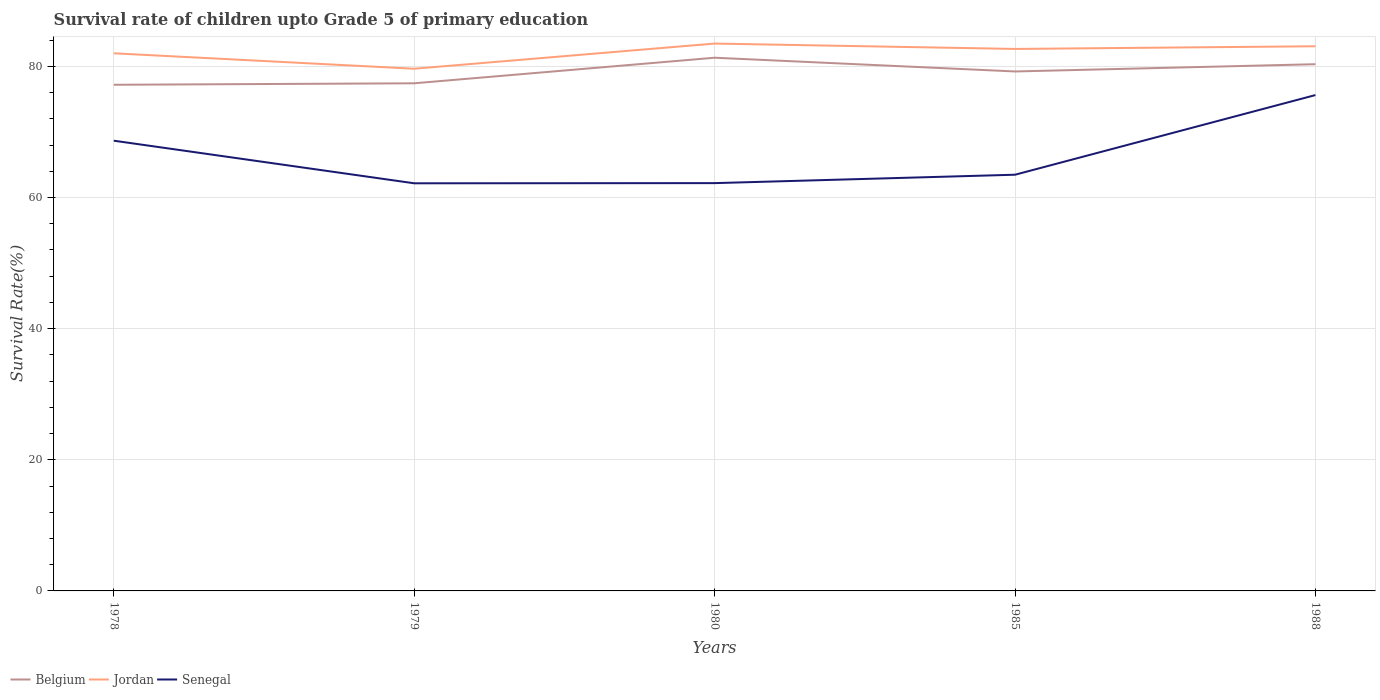Does the line corresponding to Jordan intersect with the line corresponding to Senegal?
Provide a succinct answer. No. Across all years, what is the maximum survival rate of children in Senegal?
Your answer should be compact. 62.16. In which year was the survival rate of children in Senegal maximum?
Make the answer very short. 1979. What is the total survival rate of children in Jordan in the graph?
Your response must be concise. -3.42. What is the difference between the highest and the second highest survival rate of children in Senegal?
Make the answer very short. 13.45. What is the difference between the highest and the lowest survival rate of children in Jordan?
Keep it short and to the point. 3. Is the survival rate of children in Belgium strictly greater than the survival rate of children in Senegal over the years?
Provide a short and direct response. No. Are the values on the major ticks of Y-axis written in scientific E-notation?
Make the answer very short. No. Does the graph contain any zero values?
Keep it short and to the point. No. Does the graph contain grids?
Provide a succinct answer. Yes. How many legend labels are there?
Your answer should be very brief. 3. What is the title of the graph?
Offer a terse response. Survival rate of children upto Grade 5 of primary education. Does "Sub-Saharan Africa (all income levels)" appear as one of the legend labels in the graph?
Your answer should be very brief. No. What is the label or title of the Y-axis?
Make the answer very short. Survival Rate(%). What is the Survival Rate(%) in Belgium in 1978?
Your answer should be very brief. 77.19. What is the Survival Rate(%) of Jordan in 1978?
Offer a very short reply. 81.99. What is the Survival Rate(%) of Senegal in 1978?
Your answer should be compact. 68.66. What is the Survival Rate(%) in Belgium in 1979?
Make the answer very short. 77.41. What is the Survival Rate(%) in Jordan in 1979?
Offer a terse response. 79.63. What is the Survival Rate(%) of Senegal in 1979?
Give a very brief answer. 62.16. What is the Survival Rate(%) of Belgium in 1980?
Give a very brief answer. 81.31. What is the Survival Rate(%) of Jordan in 1980?
Make the answer very short. 83.47. What is the Survival Rate(%) in Senegal in 1980?
Keep it short and to the point. 62.19. What is the Survival Rate(%) in Belgium in 1985?
Your response must be concise. 79.22. What is the Survival Rate(%) in Jordan in 1985?
Make the answer very short. 82.65. What is the Survival Rate(%) of Senegal in 1985?
Provide a succinct answer. 63.47. What is the Survival Rate(%) in Belgium in 1988?
Offer a very short reply. 80.32. What is the Survival Rate(%) in Jordan in 1988?
Ensure brevity in your answer.  83.06. What is the Survival Rate(%) in Senegal in 1988?
Offer a terse response. 75.62. Across all years, what is the maximum Survival Rate(%) of Belgium?
Provide a succinct answer. 81.31. Across all years, what is the maximum Survival Rate(%) in Jordan?
Keep it short and to the point. 83.47. Across all years, what is the maximum Survival Rate(%) of Senegal?
Ensure brevity in your answer.  75.62. Across all years, what is the minimum Survival Rate(%) of Belgium?
Offer a very short reply. 77.19. Across all years, what is the minimum Survival Rate(%) of Jordan?
Provide a short and direct response. 79.63. Across all years, what is the minimum Survival Rate(%) of Senegal?
Keep it short and to the point. 62.16. What is the total Survival Rate(%) in Belgium in the graph?
Your answer should be compact. 395.46. What is the total Survival Rate(%) in Jordan in the graph?
Offer a terse response. 410.81. What is the total Survival Rate(%) of Senegal in the graph?
Give a very brief answer. 332.1. What is the difference between the Survival Rate(%) of Belgium in 1978 and that in 1979?
Offer a very short reply. -0.22. What is the difference between the Survival Rate(%) in Jordan in 1978 and that in 1979?
Ensure brevity in your answer.  2.35. What is the difference between the Survival Rate(%) in Senegal in 1978 and that in 1979?
Your response must be concise. 6.5. What is the difference between the Survival Rate(%) in Belgium in 1978 and that in 1980?
Keep it short and to the point. -4.12. What is the difference between the Survival Rate(%) in Jordan in 1978 and that in 1980?
Ensure brevity in your answer.  -1.48. What is the difference between the Survival Rate(%) in Senegal in 1978 and that in 1980?
Your answer should be compact. 6.47. What is the difference between the Survival Rate(%) of Belgium in 1978 and that in 1985?
Ensure brevity in your answer.  -2.03. What is the difference between the Survival Rate(%) of Jordan in 1978 and that in 1985?
Your answer should be very brief. -0.67. What is the difference between the Survival Rate(%) in Senegal in 1978 and that in 1985?
Offer a terse response. 5.19. What is the difference between the Survival Rate(%) in Belgium in 1978 and that in 1988?
Provide a short and direct response. -3.13. What is the difference between the Survival Rate(%) in Jordan in 1978 and that in 1988?
Make the answer very short. -1.07. What is the difference between the Survival Rate(%) in Senegal in 1978 and that in 1988?
Provide a short and direct response. -6.96. What is the difference between the Survival Rate(%) of Belgium in 1979 and that in 1980?
Ensure brevity in your answer.  -3.9. What is the difference between the Survival Rate(%) of Jordan in 1979 and that in 1980?
Give a very brief answer. -3.84. What is the difference between the Survival Rate(%) of Senegal in 1979 and that in 1980?
Provide a short and direct response. -0.02. What is the difference between the Survival Rate(%) of Belgium in 1979 and that in 1985?
Provide a succinct answer. -1.8. What is the difference between the Survival Rate(%) in Jordan in 1979 and that in 1985?
Your response must be concise. -3.02. What is the difference between the Survival Rate(%) of Senegal in 1979 and that in 1985?
Your answer should be compact. -1.31. What is the difference between the Survival Rate(%) in Belgium in 1979 and that in 1988?
Provide a short and direct response. -2.91. What is the difference between the Survival Rate(%) in Jordan in 1979 and that in 1988?
Provide a succinct answer. -3.42. What is the difference between the Survival Rate(%) of Senegal in 1979 and that in 1988?
Keep it short and to the point. -13.45. What is the difference between the Survival Rate(%) of Belgium in 1980 and that in 1985?
Make the answer very short. 2.1. What is the difference between the Survival Rate(%) of Jordan in 1980 and that in 1985?
Make the answer very short. 0.82. What is the difference between the Survival Rate(%) of Senegal in 1980 and that in 1985?
Your answer should be very brief. -1.28. What is the difference between the Survival Rate(%) in Belgium in 1980 and that in 1988?
Make the answer very short. 0.99. What is the difference between the Survival Rate(%) of Jordan in 1980 and that in 1988?
Make the answer very short. 0.41. What is the difference between the Survival Rate(%) of Senegal in 1980 and that in 1988?
Your response must be concise. -13.43. What is the difference between the Survival Rate(%) in Belgium in 1985 and that in 1988?
Provide a short and direct response. -1.11. What is the difference between the Survival Rate(%) in Jordan in 1985 and that in 1988?
Offer a very short reply. -0.41. What is the difference between the Survival Rate(%) of Senegal in 1985 and that in 1988?
Your response must be concise. -12.15. What is the difference between the Survival Rate(%) in Belgium in 1978 and the Survival Rate(%) in Jordan in 1979?
Give a very brief answer. -2.44. What is the difference between the Survival Rate(%) in Belgium in 1978 and the Survival Rate(%) in Senegal in 1979?
Your answer should be very brief. 15.03. What is the difference between the Survival Rate(%) in Jordan in 1978 and the Survival Rate(%) in Senegal in 1979?
Keep it short and to the point. 19.82. What is the difference between the Survival Rate(%) of Belgium in 1978 and the Survival Rate(%) of Jordan in 1980?
Offer a terse response. -6.28. What is the difference between the Survival Rate(%) in Belgium in 1978 and the Survival Rate(%) in Senegal in 1980?
Your response must be concise. 15. What is the difference between the Survival Rate(%) of Jordan in 1978 and the Survival Rate(%) of Senegal in 1980?
Offer a terse response. 19.8. What is the difference between the Survival Rate(%) in Belgium in 1978 and the Survival Rate(%) in Jordan in 1985?
Your response must be concise. -5.46. What is the difference between the Survival Rate(%) of Belgium in 1978 and the Survival Rate(%) of Senegal in 1985?
Make the answer very short. 13.72. What is the difference between the Survival Rate(%) of Jordan in 1978 and the Survival Rate(%) of Senegal in 1985?
Your response must be concise. 18.52. What is the difference between the Survival Rate(%) in Belgium in 1978 and the Survival Rate(%) in Jordan in 1988?
Your answer should be very brief. -5.87. What is the difference between the Survival Rate(%) of Belgium in 1978 and the Survival Rate(%) of Senegal in 1988?
Your answer should be compact. 1.57. What is the difference between the Survival Rate(%) in Jordan in 1978 and the Survival Rate(%) in Senegal in 1988?
Your response must be concise. 6.37. What is the difference between the Survival Rate(%) in Belgium in 1979 and the Survival Rate(%) in Jordan in 1980?
Ensure brevity in your answer.  -6.06. What is the difference between the Survival Rate(%) in Belgium in 1979 and the Survival Rate(%) in Senegal in 1980?
Give a very brief answer. 15.23. What is the difference between the Survival Rate(%) in Jordan in 1979 and the Survival Rate(%) in Senegal in 1980?
Offer a terse response. 17.45. What is the difference between the Survival Rate(%) of Belgium in 1979 and the Survival Rate(%) of Jordan in 1985?
Your response must be concise. -5.24. What is the difference between the Survival Rate(%) of Belgium in 1979 and the Survival Rate(%) of Senegal in 1985?
Provide a succinct answer. 13.94. What is the difference between the Survival Rate(%) of Jordan in 1979 and the Survival Rate(%) of Senegal in 1985?
Offer a terse response. 16.16. What is the difference between the Survival Rate(%) of Belgium in 1979 and the Survival Rate(%) of Jordan in 1988?
Give a very brief answer. -5.65. What is the difference between the Survival Rate(%) in Belgium in 1979 and the Survival Rate(%) in Senegal in 1988?
Your answer should be very brief. 1.8. What is the difference between the Survival Rate(%) in Jordan in 1979 and the Survival Rate(%) in Senegal in 1988?
Your answer should be very brief. 4.02. What is the difference between the Survival Rate(%) in Belgium in 1980 and the Survival Rate(%) in Jordan in 1985?
Provide a short and direct response. -1.34. What is the difference between the Survival Rate(%) in Belgium in 1980 and the Survival Rate(%) in Senegal in 1985?
Offer a very short reply. 17.84. What is the difference between the Survival Rate(%) of Jordan in 1980 and the Survival Rate(%) of Senegal in 1985?
Ensure brevity in your answer.  20. What is the difference between the Survival Rate(%) in Belgium in 1980 and the Survival Rate(%) in Jordan in 1988?
Provide a short and direct response. -1.75. What is the difference between the Survival Rate(%) in Belgium in 1980 and the Survival Rate(%) in Senegal in 1988?
Your answer should be compact. 5.7. What is the difference between the Survival Rate(%) in Jordan in 1980 and the Survival Rate(%) in Senegal in 1988?
Keep it short and to the point. 7.86. What is the difference between the Survival Rate(%) in Belgium in 1985 and the Survival Rate(%) in Jordan in 1988?
Your answer should be very brief. -3.84. What is the difference between the Survival Rate(%) of Belgium in 1985 and the Survival Rate(%) of Senegal in 1988?
Your answer should be very brief. 3.6. What is the difference between the Survival Rate(%) in Jordan in 1985 and the Survival Rate(%) in Senegal in 1988?
Provide a short and direct response. 7.04. What is the average Survival Rate(%) of Belgium per year?
Your answer should be compact. 79.09. What is the average Survival Rate(%) in Jordan per year?
Keep it short and to the point. 82.16. What is the average Survival Rate(%) in Senegal per year?
Provide a short and direct response. 66.42. In the year 1978, what is the difference between the Survival Rate(%) of Belgium and Survival Rate(%) of Jordan?
Offer a very short reply. -4.8. In the year 1978, what is the difference between the Survival Rate(%) in Belgium and Survival Rate(%) in Senegal?
Provide a succinct answer. 8.53. In the year 1978, what is the difference between the Survival Rate(%) in Jordan and Survival Rate(%) in Senegal?
Ensure brevity in your answer.  13.33. In the year 1979, what is the difference between the Survival Rate(%) of Belgium and Survival Rate(%) of Jordan?
Keep it short and to the point. -2.22. In the year 1979, what is the difference between the Survival Rate(%) in Belgium and Survival Rate(%) in Senegal?
Give a very brief answer. 15.25. In the year 1979, what is the difference between the Survival Rate(%) of Jordan and Survival Rate(%) of Senegal?
Your answer should be compact. 17.47. In the year 1980, what is the difference between the Survival Rate(%) in Belgium and Survival Rate(%) in Jordan?
Make the answer very short. -2.16. In the year 1980, what is the difference between the Survival Rate(%) of Belgium and Survival Rate(%) of Senegal?
Provide a succinct answer. 19.12. In the year 1980, what is the difference between the Survival Rate(%) in Jordan and Survival Rate(%) in Senegal?
Offer a terse response. 21.28. In the year 1985, what is the difference between the Survival Rate(%) of Belgium and Survival Rate(%) of Jordan?
Make the answer very short. -3.44. In the year 1985, what is the difference between the Survival Rate(%) in Belgium and Survival Rate(%) in Senegal?
Give a very brief answer. 15.75. In the year 1985, what is the difference between the Survival Rate(%) in Jordan and Survival Rate(%) in Senegal?
Provide a short and direct response. 19.18. In the year 1988, what is the difference between the Survival Rate(%) of Belgium and Survival Rate(%) of Jordan?
Your response must be concise. -2.73. In the year 1988, what is the difference between the Survival Rate(%) in Belgium and Survival Rate(%) in Senegal?
Ensure brevity in your answer.  4.71. In the year 1988, what is the difference between the Survival Rate(%) in Jordan and Survival Rate(%) in Senegal?
Your answer should be very brief. 7.44. What is the ratio of the Survival Rate(%) of Jordan in 1978 to that in 1979?
Give a very brief answer. 1.03. What is the ratio of the Survival Rate(%) of Senegal in 1978 to that in 1979?
Keep it short and to the point. 1.1. What is the ratio of the Survival Rate(%) of Belgium in 1978 to that in 1980?
Offer a terse response. 0.95. What is the ratio of the Survival Rate(%) of Jordan in 1978 to that in 1980?
Your answer should be compact. 0.98. What is the ratio of the Survival Rate(%) in Senegal in 1978 to that in 1980?
Your answer should be compact. 1.1. What is the ratio of the Survival Rate(%) of Belgium in 1978 to that in 1985?
Your answer should be very brief. 0.97. What is the ratio of the Survival Rate(%) of Jordan in 1978 to that in 1985?
Provide a short and direct response. 0.99. What is the ratio of the Survival Rate(%) of Senegal in 1978 to that in 1985?
Give a very brief answer. 1.08. What is the ratio of the Survival Rate(%) in Jordan in 1978 to that in 1988?
Your response must be concise. 0.99. What is the ratio of the Survival Rate(%) of Senegal in 1978 to that in 1988?
Provide a short and direct response. 0.91. What is the ratio of the Survival Rate(%) in Belgium in 1979 to that in 1980?
Your response must be concise. 0.95. What is the ratio of the Survival Rate(%) of Jordan in 1979 to that in 1980?
Keep it short and to the point. 0.95. What is the ratio of the Survival Rate(%) in Senegal in 1979 to that in 1980?
Provide a succinct answer. 1. What is the ratio of the Survival Rate(%) in Belgium in 1979 to that in 1985?
Make the answer very short. 0.98. What is the ratio of the Survival Rate(%) in Jordan in 1979 to that in 1985?
Your answer should be compact. 0.96. What is the ratio of the Survival Rate(%) of Senegal in 1979 to that in 1985?
Offer a very short reply. 0.98. What is the ratio of the Survival Rate(%) in Belgium in 1979 to that in 1988?
Ensure brevity in your answer.  0.96. What is the ratio of the Survival Rate(%) in Jordan in 1979 to that in 1988?
Your answer should be compact. 0.96. What is the ratio of the Survival Rate(%) of Senegal in 1979 to that in 1988?
Ensure brevity in your answer.  0.82. What is the ratio of the Survival Rate(%) of Belgium in 1980 to that in 1985?
Provide a short and direct response. 1.03. What is the ratio of the Survival Rate(%) of Jordan in 1980 to that in 1985?
Make the answer very short. 1.01. What is the ratio of the Survival Rate(%) of Senegal in 1980 to that in 1985?
Your answer should be compact. 0.98. What is the ratio of the Survival Rate(%) of Belgium in 1980 to that in 1988?
Offer a very short reply. 1.01. What is the ratio of the Survival Rate(%) in Jordan in 1980 to that in 1988?
Offer a very short reply. 1. What is the ratio of the Survival Rate(%) in Senegal in 1980 to that in 1988?
Your answer should be compact. 0.82. What is the ratio of the Survival Rate(%) of Belgium in 1985 to that in 1988?
Give a very brief answer. 0.99. What is the ratio of the Survival Rate(%) in Senegal in 1985 to that in 1988?
Offer a very short reply. 0.84. What is the difference between the highest and the second highest Survival Rate(%) of Belgium?
Provide a succinct answer. 0.99. What is the difference between the highest and the second highest Survival Rate(%) of Jordan?
Give a very brief answer. 0.41. What is the difference between the highest and the second highest Survival Rate(%) in Senegal?
Make the answer very short. 6.96. What is the difference between the highest and the lowest Survival Rate(%) in Belgium?
Provide a short and direct response. 4.12. What is the difference between the highest and the lowest Survival Rate(%) in Jordan?
Make the answer very short. 3.84. What is the difference between the highest and the lowest Survival Rate(%) in Senegal?
Offer a very short reply. 13.45. 